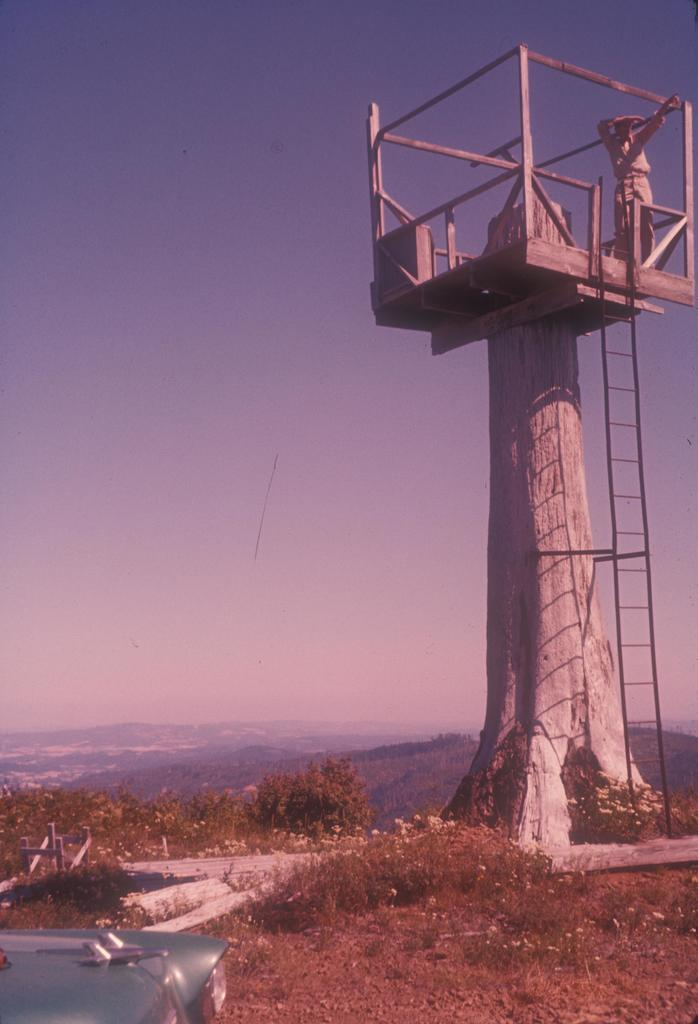What is the main structure in the image? There is a tower in the image. Can you describe the person in the image? There is a person standing in the image. What can be seen in the background of the image? There are trees in the background of the image. What is the color of the trees? The trees are green in color. What is visible above the tower and trees? The sky is visible in the image. What are the colors of the sky? The sky is blue and white in color. Where is the nest located in the image? There is no nest present in the image. What type of account is being discussed in the image? There is no account being discussed in the image. 